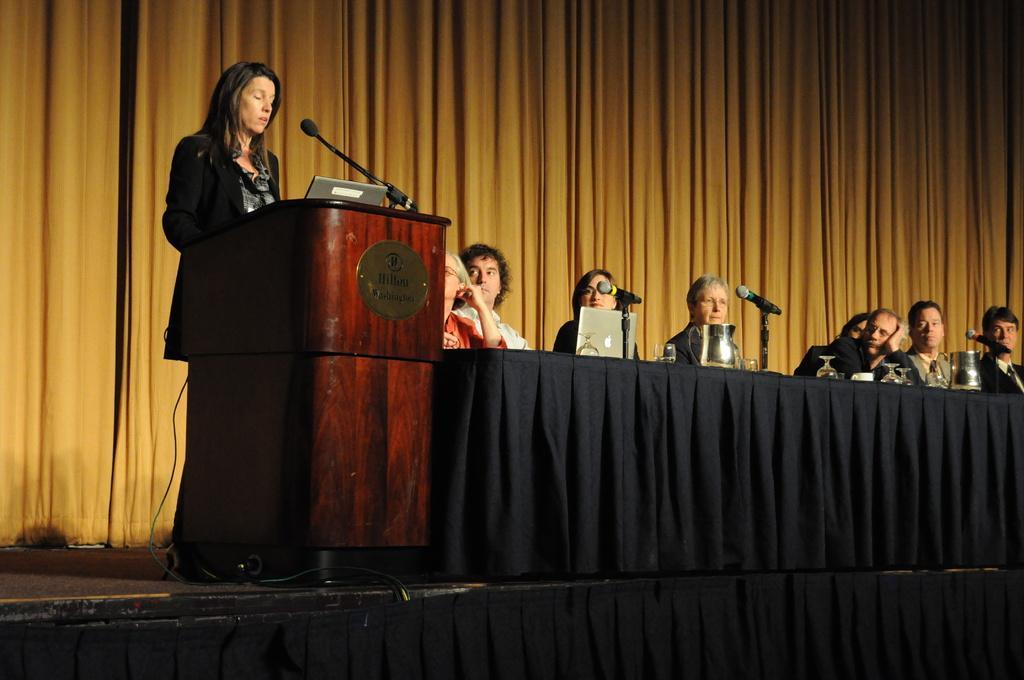In one or two sentences, can you explain what this image depicts? This picture is clicked inside. On the left there is a woman wearing black color blazer and standing behind the wooden podium and we can see a microphone is attached to the podium. On the right we can see the group of people seems to be sitting on the chairs and we can see the microphones, glasses, laptop and some other items are placed on the top of the table. In the background we can see the curtains. 